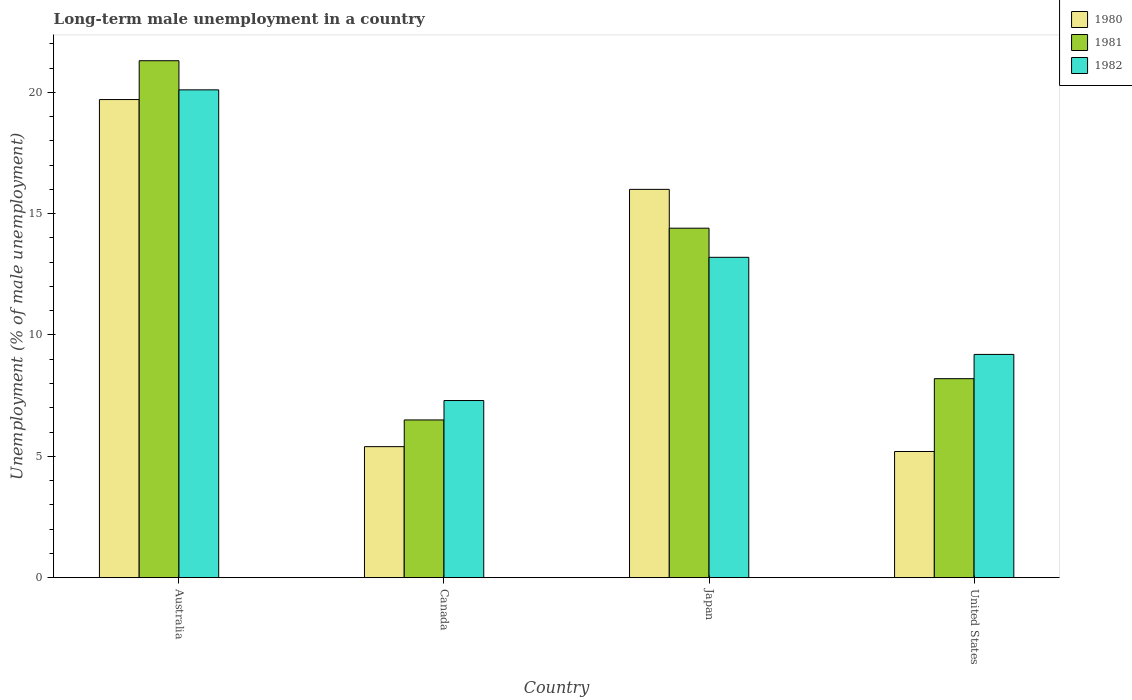Are the number of bars per tick equal to the number of legend labels?
Provide a short and direct response. Yes. Are the number of bars on each tick of the X-axis equal?
Make the answer very short. Yes. How many bars are there on the 4th tick from the left?
Offer a very short reply. 3. What is the label of the 1st group of bars from the left?
Your answer should be very brief. Australia. What is the percentage of long-term unemployed male population in 1980 in Canada?
Offer a very short reply. 5.4. Across all countries, what is the maximum percentage of long-term unemployed male population in 1980?
Provide a succinct answer. 19.7. Across all countries, what is the minimum percentage of long-term unemployed male population in 1981?
Provide a short and direct response. 6.5. In which country was the percentage of long-term unemployed male population in 1980 minimum?
Your answer should be compact. United States. What is the total percentage of long-term unemployed male population in 1980 in the graph?
Give a very brief answer. 46.3. What is the difference between the percentage of long-term unemployed male population in 1981 in Australia and that in Canada?
Your answer should be very brief. 14.8. What is the difference between the percentage of long-term unemployed male population in 1981 in Australia and the percentage of long-term unemployed male population in 1982 in United States?
Keep it short and to the point. 12.1. What is the average percentage of long-term unemployed male population in 1982 per country?
Provide a succinct answer. 12.45. What is the difference between the percentage of long-term unemployed male population of/in 1982 and percentage of long-term unemployed male population of/in 1981 in United States?
Your answer should be very brief. 1. What is the ratio of the percentage of long-term unemployed male population in 1982 in Australia to that in Japan?
Provide a succinct answer. 1.52. Is the percentage of long-term unemployed male population in 1982 in Canada less than that in Japan?
Make the answer very short. Yes. Is the difference between the percentage of long-term unemployed male population in 1982 in Canada and Japan greater than the difference between the percentage of long-term unemployed male population in 1981 in Canada and Japan?
Provide a short and direct response. Yes. What is the difference between the highest and the second highest percentage of long-term unemployed male population in 1980?
Provide a short and direct response. -3.7. What is the difference between the highest and the lowest percentage of long-term unemployed male population in 1981?
Make the answer very short. 14.8. Is the sum of the percentage of long-term unemployed male population in 1980 in Australia and Japan greater than the maximum percentage of long-term unemployed male population in 1982 across all countries?
Your answer should be very brief. Yes. What does the 2nd bar from the right in Australia represents?
Give a very brief answer. 1981. How many bars are there?
Give a very brief answer. 12. Are all the bars in the graph horizontal?
Your response must be concise. No. How many countries are there in the graph?
Keep it short and to the point. 4. What is the difference between two consecutive major ticks on the Y-axis?
Keep it short and to the point. 5. Where does the legend appear in the graph?
Provide a succinct answer. Top right. How many legend labels are there?
Give a very brief answer. 3. How are the legend labels stacked?
Give a very brief answer. Vertical. What is the title of the graph?
Your answer should be very brief. Long-term male unemployment in a country. What is the label or title of the X-axis?
Offer a terse response. Country. What is the label or title of the Y-axis?
Offer a terse response. Unemployment (% of male unemployment). What is the Unemployment (% of male unemployment) in 1980 in Australia?
Make the answer very short. 19.7. What is the Unemployment (% of male unemployment) in 1981 in Australia?
Keep it short and to the point. 21.3. What is the Unemployment (% of male unemployment) in 1982 in Australia?
Provide a succinct answer. 20.1. What is the Unemployment (% of male unemployment) of 1980 in Canada?
Your answer should be compact. 5.4. What is the Unemployment (% of male unemployment) in 1981 in Canada?
Provide a succinct answer. 6.5. What is the Unemployment (% of male unemployment) in 1982 in Canada?
Give a very brief answer. 7.3. What is the Unemployment (% of male unemployment) in 1980 in Japan?
Give a very brief answer. 16. What is the Unemployment (% of male unemployment) in 1981 in Japan?
Your answer should be compact. 14.4. What is the Unemployment (% of male unemployment) of 1982 in Japan?
Offer a very short reply. 13.2. What is the Unemployment (% of male unemployment) of 1980 in United States?
Provide a succinct answer. 5.2. What is the Unemployment (% of male unemployment) of 1981 in United States?
Your response must be concise. 8.2. What is the Unemployment (% of male unemployment) in 1982 in United States?
Provide a short and direct response. 9.2. Across all countries, what is the maximum Unemployment (% of male unemployment) in 1980?
Provide a short and direct response. 19.7. Across all countries, what is the maximum Unemployment (% of male unemployment) in 1981?
Offer a terse response. 21.3. Across all countries, what is the maximum Unemployment (% of male unemployment) in 1982?
Offer a terse response. 20.1. Across all countries, what is the minimum Unemployment (% of male unemployment) of 1980?
Your response must be concise. 5.2. Across all countries, what is the minimum Unemployment (% of male unemployment) of 1982?
Give a very brief answer. 7.3. What is the total Unemployment (% of male unemployment) of 1980 in the graph?
Keep it short and to the point. 46.3. What is the total Unemployment (% of male unemployment) of 1981 in the graph?
Provide a short and direct response. 50.4. What is the total Unemployment (% of male unemployment) in 1982 in the graph?
Your answer should be compact. 49.8. What is the difference between the Unemployment (% of male unemployment) of 1982 in Australia and that in Japan?
Provide a short and direct response. 6.9. What is the difference between the Unemployment (% of male unemployment) in 1980 in Australia and that in United States?
Offer a terse response. 14.5. What is the difference between the Unemployment (% of male unemployment) in 1982 in Australia and that in United States?
Ensure brevity in your answer.  10.9. What is the difference between the Unemployment (% of male unemployment) of 1980 in Canada and that in Japan?
Your answer should be compact. -10.6. What is the difference between the Unemployment (% of male unemployment) of 1982 in Canada and that in Japan?
Give a very brief answer. -5.9. What is the difference between the Unemployment (% of male unemployment) of 1980 in Canada and that in United States?
Offer a very short reply. 0.2. What is the difference between the Unemployment (% of male unemployment) of 1982 in Canada and that in United States?
Make the answer very short. -1.9. What is the difference between the Unemployment (% of male unemployment) of 1980 in Australia and the Unemployment (% of male unemployment) of 1981 in Canada?
Provide a short and direct response. 13.2. What is the difference between the Unemployment (% of male unemployment) of 1981 in Australia and the Unemployment (% of male unemployment) of 1982 in Canada?
Ensure brevity in your answer.  14. What is the difference between the Unemployment (% of male unemployment) in 1980 in Australia and the Unemployment (% of male unemployment) in 1981 in Japan?
Provide a short and direct response. 5.3. What is the difference between the Unemployment (% of male unemployment) in 1980 in Canada and the Unemployment (% of male unemployment) in 1982 in Japan?
Give a very brief answer. -7.8. What is the difference between the Unemployment (% of male unemployment) of 1981 in Canada and the Unemployment (% of male unemployment) of 1982 in Japan?
Give a very brief answer. -6.7. What is the difference between the Unemployment (% of male unemployment) of 1980 in Canada and the Unemployment (% of male unemployment) of 1981 in United States?
Give a very brief answer. -2.8. What is the difference between the Unemployment (% of male unemployment) of 1981 in Canada and the Unemployment (% of male unemployment) of 1982 in United States?
Provide a succinct answer. -2.7. What is the difference between the Unemployment (% of male unemployment) of 1980 in Japan and the Unemployment (% of male unemployment) of 1982 in United States?
Your answer should be very brief. 6.8. What is the average Unemployment (% of male unemployment) of 1980 per country?
Your response must be concise. 11.57. What is the average Unemployment (% of male unemployment) of 1981 per country?
Give a very brief answer. 12.6. What is the average Unemployment (% of male unemployment) of 1982 per country?
Make the answer very short. 12.45. What is the difference between the Unemployment (% of male unemployment) of 1980 and Unemployment (% of male unemployment) of 1981 in Australia?
Ensure brevity in your answer.  -1.6. What is the difference between the Unemployment (% of male unemployment) of 1980 and Unemployment (% of male unemployment) of 1982 in Australia?
Offer a terse response. -0.4. What is the difference between the Unemployment (% of male unemployment) in 1980 and Unemployment (% of male unemployment) in 1981 in United States?
Make the answer very short. -3. What is the difference between the Unemployment (% of male unemployment) of 1981 and Unemployment (% of male unemployment) of 1982 in United States?
Your answer should be compact. -1. What is the ratio of the Unemployment (% of male unemployment) of 1980 in Australia to that in Canada?
Your answer should be compact. 3.65. What is the ratio of the Unemployment (% of male unemployment) of 1981 in Australia to that in Canada?
Offer a terse response. 3.28. What is the ratio of the Unemployment (% of male unemployment) of 1982 in Australia to that in Canada?
Your answer should be compact. 2.75. What is the ratio of the Unemployment (% of male unemployment) in 1980 in Australia to that in Japan?
Provide a short and direct response. 1.23. What is the ratio of the Unemployment (% of male unemployment) in 1981 in Australia to that in Japan?
Keep it short and to the point. 1.48. What is the ratio of the Unemployment (% of male unemployment) of 1982 in Australia to that in Japan?
Ensure brevity in your answer.  1.52. What is the ratio of the Unemployment (% of male unemployment) of 1980 in Australia to that in United States?
Your response must be concise. 3.79. What is the ratio of the Unemployment (% of male unemployment) of 1981 in Australia to that in United States?
Make the answer very short. 2.6. What is the ratio of the Unemployment (% of male unemployment) of 1982 in Australia to that in United States?
Make the answer very short. 2.18. What is the ratio of the Unemployment (% of male unemployment) of 1980 in Canada to that in Japan?
Offer a terse response. 0.34. What is the ratio of the Unemployment (% of male unemployment) in 1981 in Canada to that in Japan?
Provide a short and direct response. 0.45. What is the ratio of the Unemployment (% of male unemployment) in 1982 in Canada to that in Japan?
Offer a terse response. 0.55. What is the ratio of the Unemployment (% of male unemployment) in 1980 in Canada to that in United States?
Provide a succinct answer. 1.04. What is the ratio of the Unemployment (% of male unemployment) of 1981 in Canada to that in United States?
Your answer should be very brief. 0.79. What is the ratio of the Unemployment (% of male unemployment) in 1982 in Canada to that in United States?
Offer a terse response. 0.79. What is the ratio of the Unemployment (% of male unemployment) in 1980 in Japan to that in United States?
Ensure brevity in your answer.  3.08. What is the ratio of the Unemployment (% of male unemployment) of 1981 in Japan to that in United States?
Provide a short and direct response. 1.76. What is the ratio of the Unemployment (% of male unemployment) of 1982 in Japan to that in United States?
Give a very brief answer. 1.43. What is the difference between the highest and the second highest Unemployment (% of male unemployment) of 1980?
Offer a terse response. 3.7. What is the difference between the highest and the second highest Unemployment (% of male unemployment) of 1981?
Provide a short and direct response. 6.9. What is the difference between the highest and the second highest Unemployment (% of male unemployment) in 1982?
Keep it short and to the point. 6.9. What is the difference between the highest and the lowest Unemployment (% of male unemployment) of 1982?
Keep it short and to the point. 12.8. 